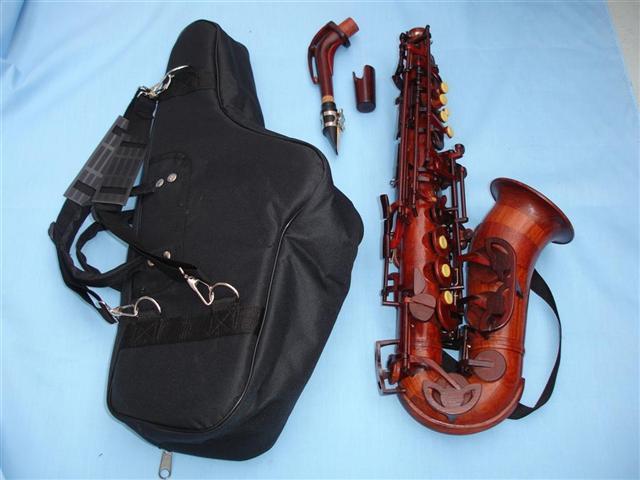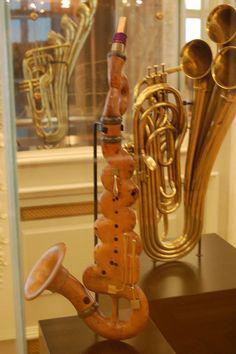The first image is the image on the left, the second image is the image on the right. Examine the images to the left and right. Is the description "There is exactly one instrument against a white background in the image on the left." accurate? Answer yes or no. No. 